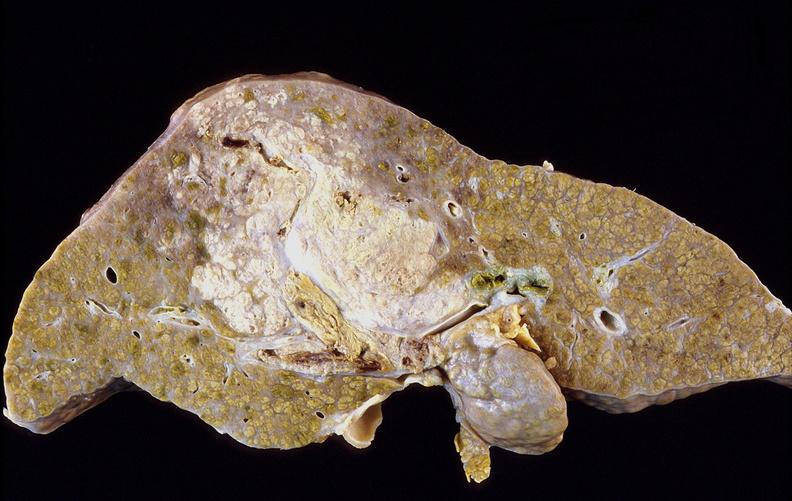what is present?
Answer the question using a single word or phrase. Hepatobiliary 